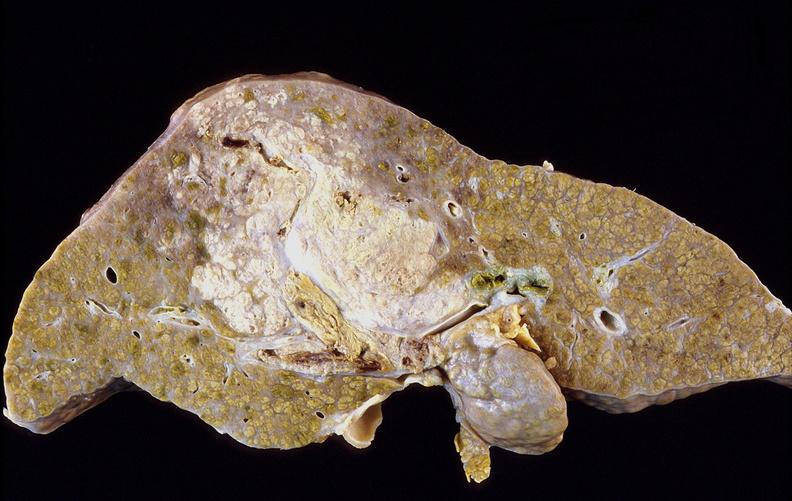what is present?
Answer the question using a single word or phrase. Hepatobiliary 